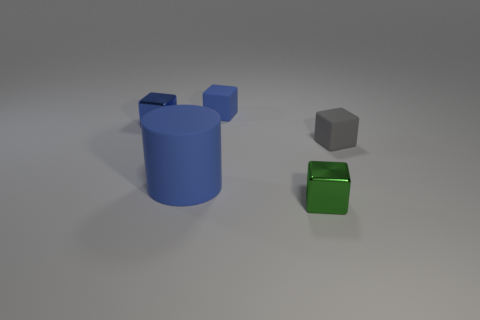Can you describe the shapes and colors in this image? Certainly! There is a large blue cylinder, a smaller cube that appears to be gray, and an even smaller green cube with a shiny surface, likely indicating it's not matte like the other objects. 